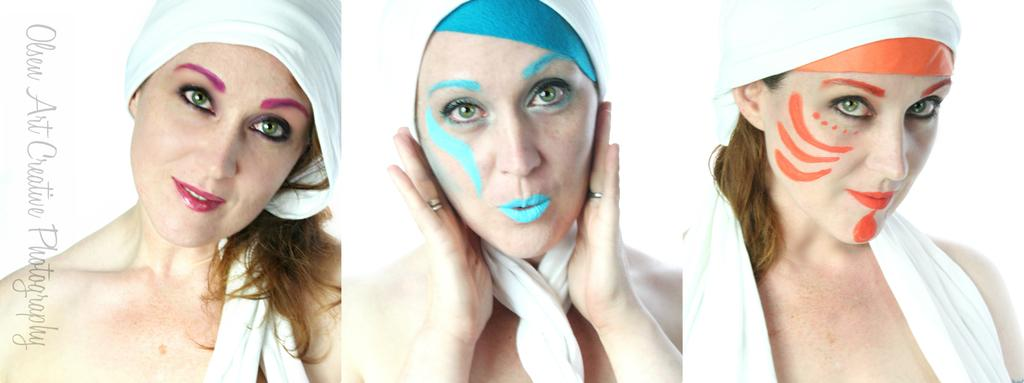Who is present in the image? There is a woman in the image. What is the woman doing in the image? The woman is standing in the image. What is the woman's facial expression in the image? The woman is smiling in the image. How is the image composed? The image is a collage. What type of cabbage is the woman holding in the image? There is no cabbage present in the image. Is the scarecrow visible in the image? There is no scarecrow present in the image. 